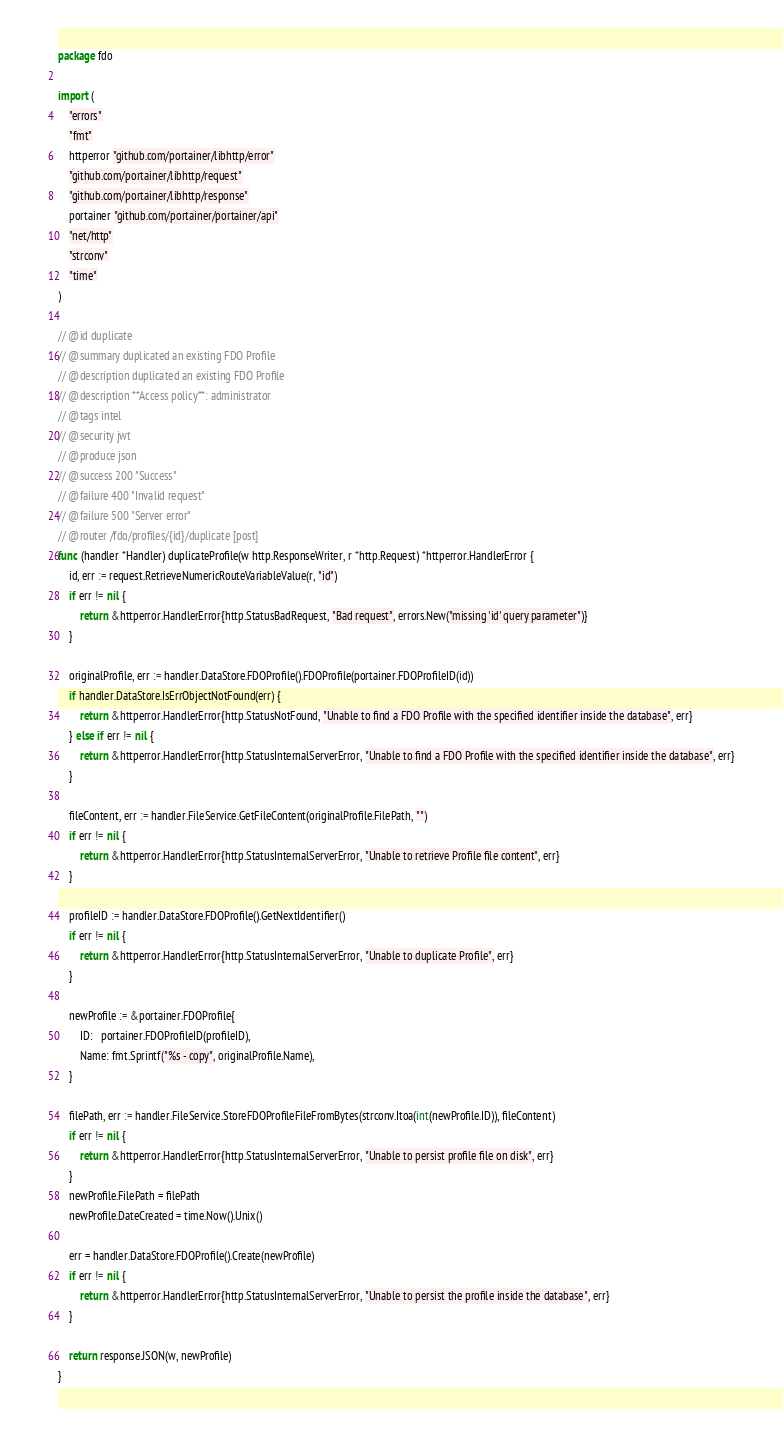<code> <loc_0><loc_0><loc_500><loc_500><_Go_>package fdo

import (
	"errors"
	"fmt"
	httperror "github.com/portainer/libhttp/error"
	"github.com/portainer/libhttp/request"
	"github.com/portainer/libhttp/response"
	portainer "github.com/portainer/portainer/api"
	"net/http"
	"strconv"
	"time"
)

// @id duplicate
// @summary duplicated an existing FDO Profile
// @description duplicated an existing FDO Profile
// @description **Access policy**: administrator
// @tags intel
// @security jwt
// @produce json
// @success 200 "Success"
// @failure 400 "Invalid request"
// @failure 500 "Server error"
// @router /fdo/profiles/{id}/duplicate [post]
func (handler *Handler) duplicateProfile(w http.ResponseWriter, r *http.Request) *httperror.HandlerError {
	id, err := request.RetrieveNumericRouteVariableValue(r, "id")
	if err != nil {
		return &httperror.HandlerError{http.StatusBadRequest, "Bad request", errors.New("missing 'id' query parameter")}
	}

	originalProfile, err := handler.DataStore.FDOProfile().FDOProfile(portainer.FDOProfileID(id))
	if handler.DataStore.IsErrObjectNotFound(err) {
		return &httperror.HandlerError{http.StatusNotFound, "Unable to find a FDO Profile with the specified identifier inside the database", err}
	} else if err != nil {
		return &httperror.HandlerError{http.StatusInternalServerError, "Unable to find a FDO Profile with the specified identifier inside the database", err}
	}

	fileContent, err := handler.FileService.GetFileContent(originalProfile.FilePath, "")
	if err != nil {
		return &httperror.HandlerError{http.StatusInternalServerError, "Unable to retrieve Profile file content", err}
	}

	profileID := handler.DataStore.FDOProfile().GetNextIdentifier()
	if err != nil {
		return &httperror.HandlerError{http.StatusInternalServerError, "Unable to duplicate Profile", err}
	}

	newProfile := &portainer.FDOProfile{
		ID:   portainer.FDOProfileID(profileID),
		Name: fmt.Sprintf("%s - copy", originalProfile.Name),
	}

	filePath, err := handler.FileService.StoreFDOProfileFileFromBytes(strconv.Itoa(int(newProfile.ID)), fileContent)
	if err != nil {
		return &httperror.HandlerError{http.StatusInternalServerError, "Unable to persist profile file on disk", err}
	}
	newProfile.FilePath = filePath
	newProfile.DateCreated = time.Now().Unix()

	err = handler.DataStore.FDOProfile().Create(newProfile)
	if err != nil {
		return &httperror.HandlerError{http.StatusInternalServerError, "Unable to persist the profile inside the database", err}
	}

	return response.JSON(w, newProfile)
}
</code> 